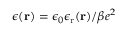<formula> <loc_0><loc_0><loc_500><loc_500>\epsilon ( r ) = \epsilon _ { 0 } \epsilon _ { r } ( r ) / \beta e ^ { 2 }</formula> 